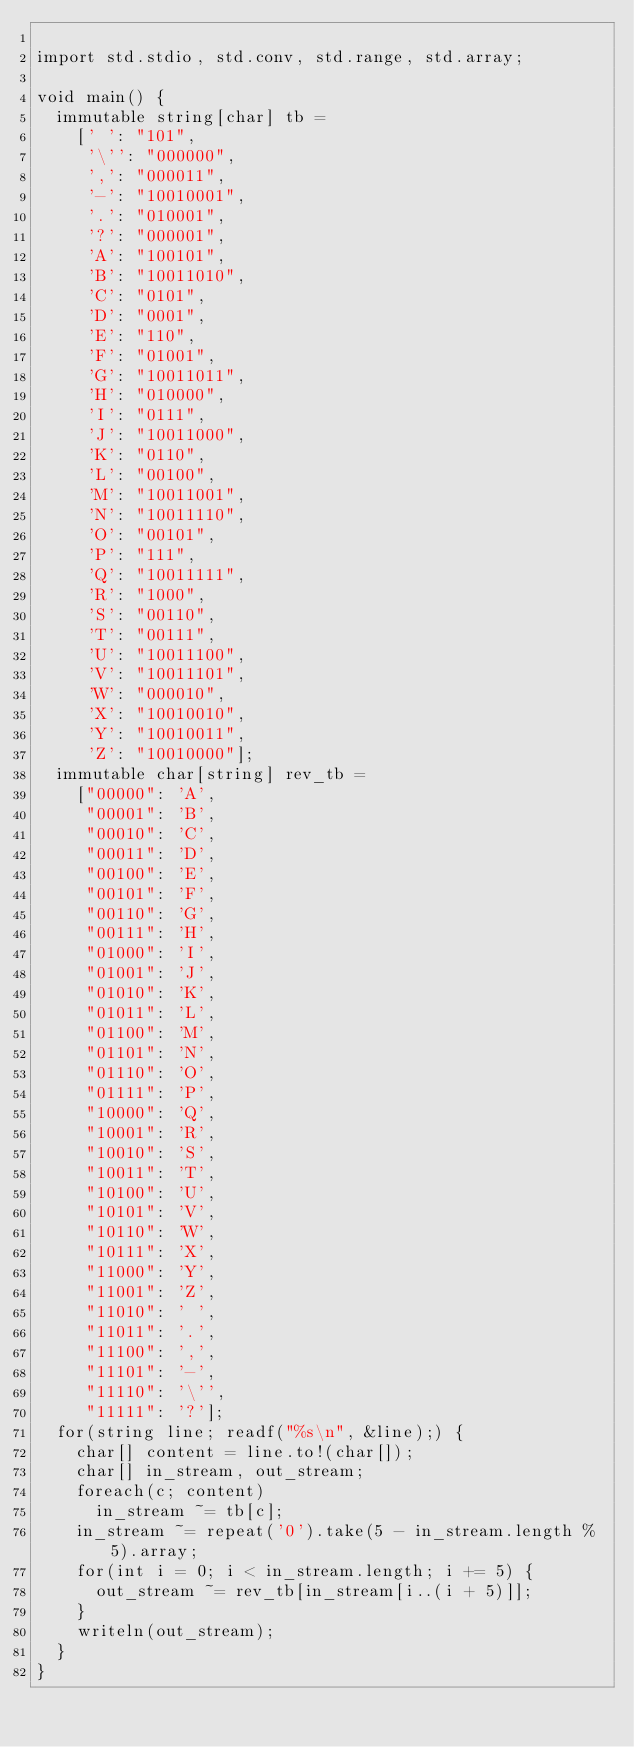Convert code to text. <code><loc_0><loc_0><loc_500><loc_500><_D_>
import std.stdio, std.conv, std.range, std.array;

void main() {
  immutable string[char] tb =
    [' ': "101",
     '\'': "000000",
     ',': "000011",
     '-': "10010001",
     '.': "010001",
     '?': "000001",
     'A': "100101",
     'B': "10011010",
     'C': "0101",
     'D': "0001",
     'E': "110",
     'F': "01001",
     'G': "10011011",
     'H': "010000",
     'I': "0111",
     'J': "10011000",
     'K': "0110",
     'L': "00100",
     'M': "10011001",
     'N': "10011110",
     'O': "00101",
     'P': "111",
     'Q': "10011111",
     'R': "1000",
     'S': "00110",
     'T': "00111",
     'U': "10011100",
     'V': "10011101",
     'W': "000010",
     'X': "10010010",
     'Y': "10010011",
     'Z': "10010000"];
  immutable char[string] rev_tb =
    ["00000": 'A',
     "00001": 'B',
     "00010": 'C',
     "00011": 'D',
     "00100": 'E',
     "00101": 'F',
     "00110": 'G',
     "00111": 'H',
     "01000": 'I',
     "01001": 'J',
     "01010": 'K',
     "01011": 'L',
     "01100": 'M',
     "01101": 'N',
     "01110": 'O',
     "01111": 'P',
     "10000": 'Q',
     "10001": 'R',
     "10010": 'S',
     "10011": 'T',
     "10100": 'U',
     "10101": 'V',
     "10110": 'W',
     "10111": 'X',
     "11000": 'Y',
     "11001": 'Z',
     "11010": ' ',
     "11011": '.',
     "11100": ',',
     "11101": '-',
     "11110": '\'',
     "11111": '?'];
  for(string line; readf("%s\n", &line);) {
    char[] content = line.to!(char[]);
    char[] in_stream, out_stream;
    foreach(c; content)
      in_stream ~= tb[c];
    in_stream ~= repeat('0').take(5 - in_stream.length % 5).array;
    for(int i = 0; i < in_stream.length; i += 5) {
      out_stream ~= rev_tb[in_stream[i..(i + 5)]];
    }
    writeln(out_stream);
  }
}</code> 